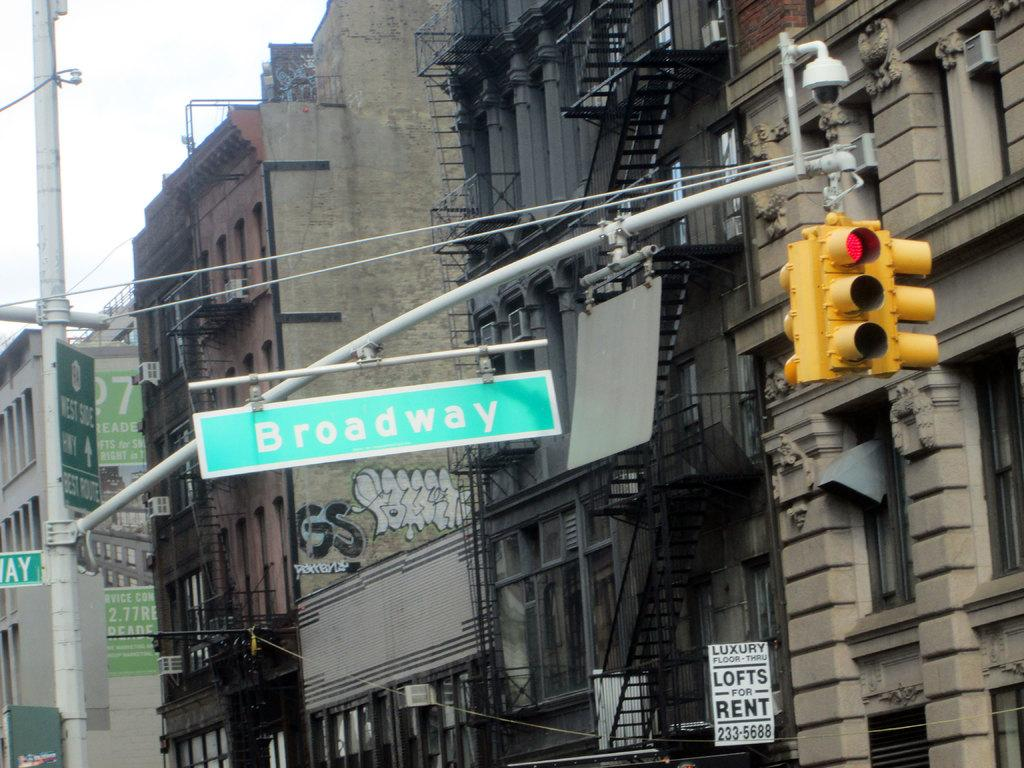<image>
Write a terse but informative summary of the picture. A black and white sign on a building says there are luxury lofts for rent. 